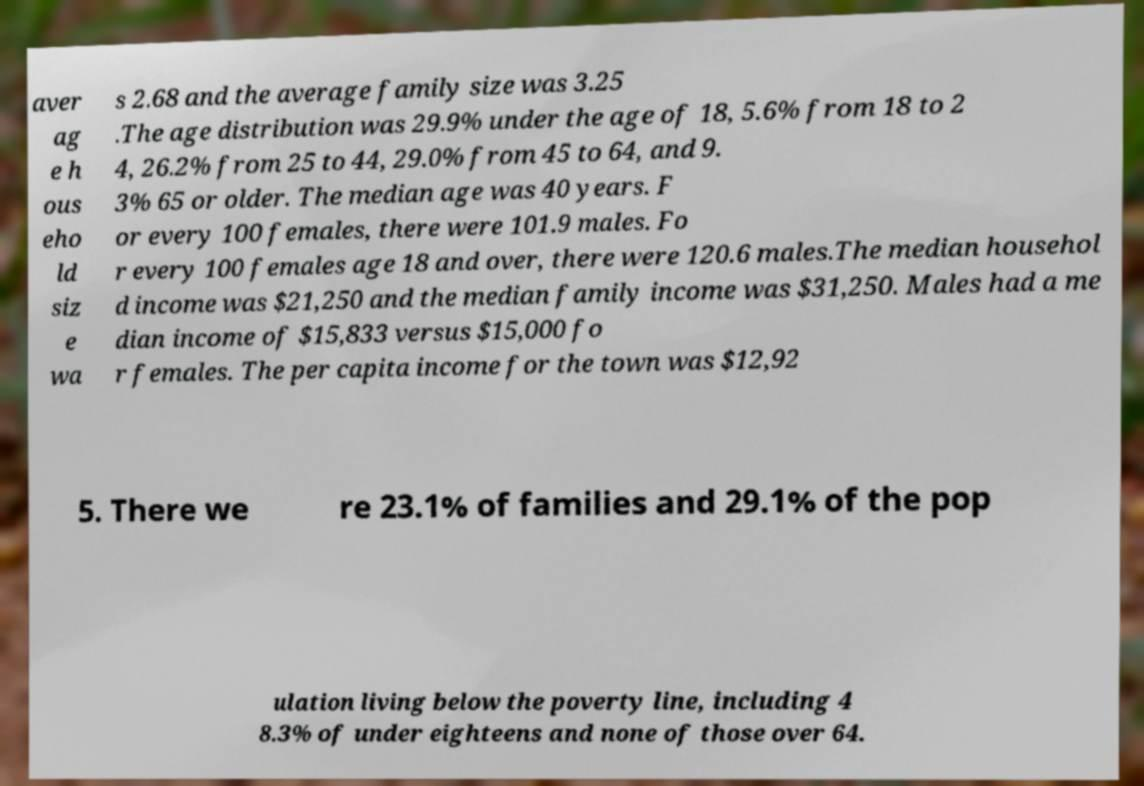Could you extract and type out the text from this image? aver ag e h ous eho ld siz e wa s 2.68 and the average family size was 3.25 .The age distribution was 29.9% under the age of 18, 5.6% from 18 to 2 4, 26.2% from 25 to 44, 29.0% from 45 to 64, and 9. 3% 65 or older. The median age was 40 years. F or every 100 females, there were 101.9 males. Fo r every 100 females age 18 and over, there were 120.6 males.The median househol d income was $21,250 and the median family income was $31,250. Males had a me dian income of $15,833 versus $15,000 fo r females. The per capita income for the town was $12,92 5. There we re 23.1% of families and 29.1% of the pop ulation living below the poverty line, including 4 8.3% of under eighteens and none of those over 64. 